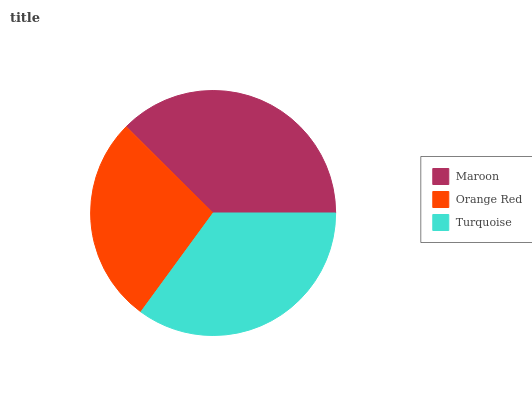Is Orange Red the minimum?
Answer yes or no. Yes. Is Maroon the maximum?
Answer yes or no. Yes. Is Turquoise the minimum?
Answer yes or no. No. Is Turquoise the maximum?
Answer yes or no. No. Is Turquoise greater than Orange Red?
Answer yes or no. Yes. Is Orange Red less than Turquoise?
Answer yes or no. Yes. Is Orange Red greater than Turquoise?
Answer yes or no. No. Is Turquoise less than Orange Red?
Answer yes or no. No. Is Turquoise the high median?
Answer yes or no. Yes. Is Turquoise the low median?
Answer yes or no. Yes. Is Maroon the high median?
Answer yes or no. No. Is Orange Red the low median?
Answer yes or no. No. 